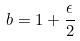Convert formula to latex. <formula><loc_0><loc_0><loc_500><loc_500>b = 1 + \frac { \epsilon } { 2 }</formula> 